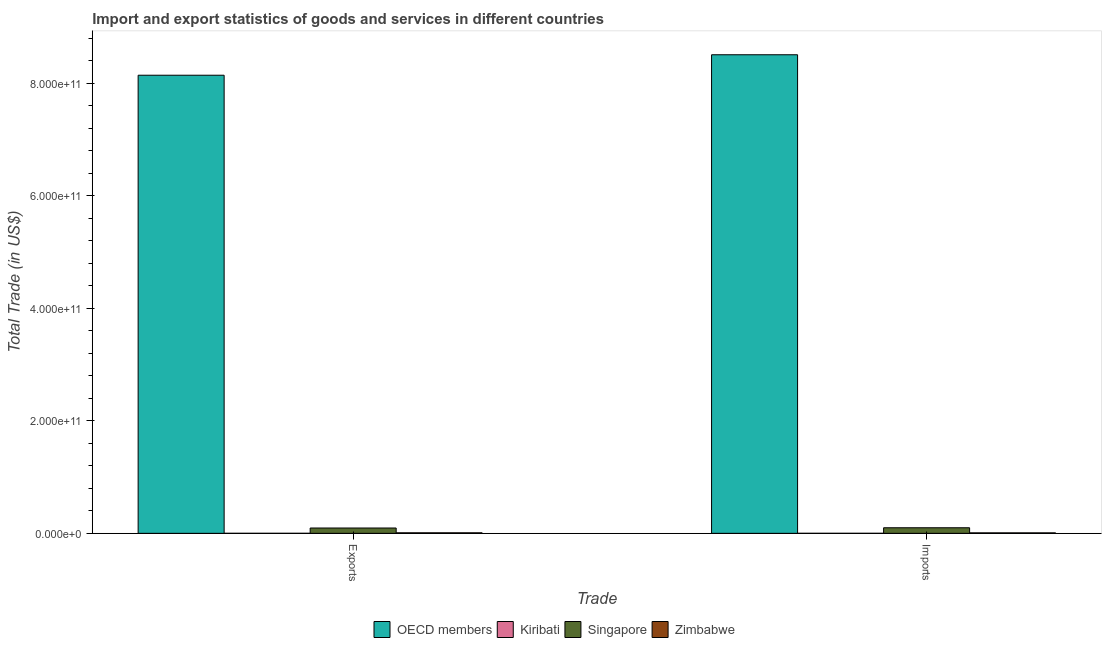How many different coloured bars are there?
Your answer should be compact. 4. Are the number of bars per tick equal to the number of legend labels?
Ensure brevity in your answer.  Yes. How many bars are there on the 1st tick from the right?
Ensure brevity in your answer.  4. What is the label of the 1st group of bars from the left?
Provide a succinct answer. Exports. What is the imports of goods and services in Singapore?
Your answer should be compact. 9.90e+09. Across all countries, what is the maximum imports of goods and services?
Provide a short and direct response. 8.51e+11. Across all countries, what is the minimum imports of goods and services?
Provide a succinct answer. 1.47e+07. In which country was the export of goods and services minimum?
Provide a short and direct response. Kiribati. What is the total imports of goods and services in the graph?
Offer a terse response. 8.61e+11. What is the difference between the export of goods and services in OECD members and that in Zimbabwe?
Provide a succinct answer. 8.13e+11. What is the difference between the export of goods and services in Kiribati and the imports of goods and services in Zimbabwe?
Provide a short and direct response. -8.23e+08. What is the average export of goods and services per country?
Provide a short and direct response. 2.06e+11. What is the difference between the imports of goods and services and export of goods and services in Kiribati?
Your response must be concise. -8.51e+06. What is the ratio of the imports of goods and services in Zimbabwe to that in Singapore?
Offer a terse response. 0.09. In how many countries, is the imports of goods and services greater than the average imports of goods and services taken over all countries?
Give a very brief answer. 1. What does the 2nd bar from the left in Exports represents?
Your answer should be compact. Kiribati. What does the 4th bar from the right in Exports represents?
Offer a very short reply. OECD members. How many bars are there?
Provide a short and direct response. 8. Are all the bars in the graph horizontal?
Your response must be concise. No. How many countries are there in the graph?
Offer a very short reply. 4. What is the difference between two consecutive major ticks on the Y-axis?
Offer a terse response. 2.00e+11. Are the values on the major ticks of Y-axis written in scientific E-notation?
Your answer should be very brief. Yes. Does the graph contain grids?
Your response must be concise. No. What is the title of the graph?
Your answer should be compact. Import and export statistics of goods and services in different countries. Does "Kuwait" appear as one of the legend labels in the graph?
Provide a succinct answer. No. What is the label or title of the X-axis?
Keep it short and to the point. Trade. What is the label or title of the Y-axis?
Provide a short and direct response. Total Trade (in US$). What is the Total Trade (in US$) of OECD members in Exports?
Your response must be concise. 8.14e+11. What is the Total Trade (in US$) of Kiribati in Exports?
Offer a very short reply. 2.32e+07. What is the Total Trade (in US$) of Singapore in Exports?
Provide a succinct answer. 9.46e+09. What is the Total Trade (in US$) in Zimbabwe in Exports?
Your response must be concise. 9.48e+08. What is the Total Trade (in US$) in OECD members in Imports?
Your answer should be very brief. 8.51e+11. What is the Total Trade (in US$) in Kiribati in Imports?
Offer a very short reply. 1.47e+07. What is the Total Trade (in US$) in Singapore in Imports?
Provide a succinct answer. 9.90e+09. What is the Total Trade (in US$) of Zimbabwe in Imports?
Your answer should be very brief. 8.46e+08. Across all Trade, what is the maximum Total Trade (in US$) of OECD members?
Ensure brevity in your answer.  8.51e+11. Across all Trade, what is the maximum Total Trade (in US$) in Kiribati?
Ensure brevity in your answer.  2.32e+07. Across all Trade, what is the maximum Total Trade (in US$) in Singapore?
Your response must be concise. 9.90e+09. Across all Trade, what is the maximum Total Trade (in US$) of Zimbabwe?
Provide a succinct answer. 9.48e+08. Across all Trade, what is the minimum Total Trade (in US$) in OECD members?
Offer a terse response. 8.14e+11. Across all Trade, what is the minimum Total Trade (in US$) in Kiribati?
Give a very brief answer. 1.47e+07. Across all Trade, what is the minimum Total Trade (in US$) in Singapore?
Provide a short and direct response. 9.46e+09. Across all Trade, what is the minimum Total Trade (in US$) of Zimbabwe?
Your answer should be very brief. 8.46e+08. What is the total Total Trade (in US$) in OECD members in the graph?
Provide a short and direct response. 1.66e+12. What is the total Total Trade (in US$) in Kiribati in the graph?
Make the answer very short. 3.79e+07. What is the total Total Trade (in US$) of Singapore in the graph?
Make the answer very short. 1.94e+1. What is the total Total Trade (in US$) in Zimbabwe in the graph?
Ensure brevity in your answer.  1.79e+09. What is the difference between the Total Trade (in US$) of OECD members in Exports and that in Imports?
Make the answer very short. -3.64e+1. What is the difference between the Total Trade (in US$) of Kiribati in Exports and that in Imports?
Your response must be concise. 8.51e+06. What is the difference between the Total Trade (in US$) in Singapore in Exports and that in Imports?
Your answer should be compact. -4.39e+08. What is the difference between the Total Trade (in US$) of Zimbabwe in Exports and that in Imports?
Offer a very short reply. 1.02e+08. What is the difference between the Total Trade (in US$) of OECD members in Exports and the Total Trade (in US$) of Kiribati in Imports?
Provide a short and direct response. 8.14e+11. What is the difference between the Total Trade (in US$) in OECD members in Exports and the Total Trade (in US$) in Singapore in Imports?
Provide a short and direct response. 8.04e+11. What is the difference between the Total Trade (in US$) of OECD members in Exports and the Total Trade (in US$) of Zimbabwe in Imports?
Provide a succinct answer. 8.13e+11. What is the difference between the Total Trade (in US$) in Kiribati in Exports and the Total Trade (in US$) in Singapore in Imports?
Ensure brevity in your answer.  -9.87e+09. What is the difference between the Total Trade (in US$) in Kiribati in Exports and the Total Trade (in US$) in Zimbabwe in Imports?
Offer a terse response. -8.23e+08. What is the difference between the Total Trade (in US$) of Singapore in Exports and the Total Trade (in US$) of Zimbabwe in Imports?
Your answer should be compact. 8.61e+09. What is the average Total Trade (in US$) in OECD members per Trade?
Provide a succinct answer. 8.32e+11. What is the average Total Trade (in US$) in Kiribati per Trade?
Provide a succinct answer. 1.89e+07. What is the average Total Trade (in US$) in Singapore per Trade?
Give a very brief answer. 9.68e+09. What is the average Total Trade (in US$) in Zimbabwe per Trade?
Ensure brevity in your answer.  8.97e+08. What is the difference between the Total Trade (in US$) of OECD members and Total Trade (in US$) of Kiribati in Exports?
Ensure brevity in your answer.  8.14e+11. What is the difference between the Total Trade (in US$) in OECD members and Total Trade (in US$) in Singapore in Exports?
Your answer should be very brief. 8.05e+11. What is the difference between the Total Trade (in US$) in OECD members and Total Trade (in US$) in Zimbabwe in Exports?
Ensure brevity in your answer.  8.13e+11. What is the difference between the Total Trade (in US$) in Kiribati and Total Trade (in US$) in Singapore in Exports?
Ensure brevity in your answer.  -9.43e+09. What is the difference between the Total Trade (in US$) of Kiribati and Total Trade (in US$) of Zimbabwe in Exports?
Give a very brief answer. -9.25e+08. What is the difference between the Total Trade (in US$) in Singapore and Total Trade (in US$) in Zimbabwe in Exports?
Offer a very short reply. 8.51e+09. What is the difference between the Total Trade (in US$) in OECD members and Total Trade (in US$) in Kiribati in Imports?
Keep it short and to the point. 8.50e+11. What is the difference between the Total Trade (in US$) of OECD members and Total Trade (in US$) of Singapore in Imports?
Give a very brief answer. 8.41e+11. What is the difference between the Total Trade (in US$) of OECD members and Total Trade (in US$) of Zimbabwe in Imports?
Make the answer very short. 8.50e+11. What is the difference between the Total Trade (in US$) in Kiribati and Total Trade (in US$) in Singapore in Imports?
Keep it short and to the point. -9.88e+09. What is the difference between the Total Trade (in US$) of Kiribati and Total Trade (in US$) of Zimbabwe in Imports?
Offer a very short reply. -8.32e+08. What is the difference between the Total Trade (in US$) of Singapore and Total Trade (in US$) of Zimbabwe in Imports?
Provide a succinct answer. 9.05e+09. What is the ratio of the Total Trade (in US$) in OECD members in Exports to that in Imports?
Ensure brevity in your answer.  0.96. What is the ratio of the Total Trade (in US$) in Kiribati in Exports to that in Imports?
Make the answer very short. 1.58. What is the ratio of the Total Trade (in US$) in Singapore in Exports to that in Imports?
Keep it short and to the point. 0.96. What is the ratio of the Total Trade (in US$) of Zimbabwe in Exports to that in Imports?
Ensure brevity in your answer.  1.12. What is the difference between the highest and the second highest Total Trade (in US$) in OECD members?
Ensure brevity in your answer.  3.64e+1. What is the difference between the highest and the second highest Total Trade (in US$) of Kiribati?
Provide a short and direct response. 8.51e+06. What is the difference between the highest and the second highest Total Trade (in US$) of Singapore?
Provide a succinct answer. 4.39e+08. What is the difference between the highest and the second highest Total Trade (in US$) of Zimbabwe?
Give a very brief answer. 1.02e+08. What is the difference between the highest and the lowest Total Trade (in US$) in OECD members?
Ensure brevity in your answer.  3.64e+1. What is the difference between the highest and the lowest Total Trade (in US$) of Kiribati?
Offer a terse response. 8.51e+06. What is the difference between the highest and the lowest Total Trade (in US$) in Singapore?
Offer a terse response. 4.39e+08. What is the difference between the highest and the lowest Total Trade (in US$) in Zimbabwe?
Your answer should be compact. 1.02e+08. 